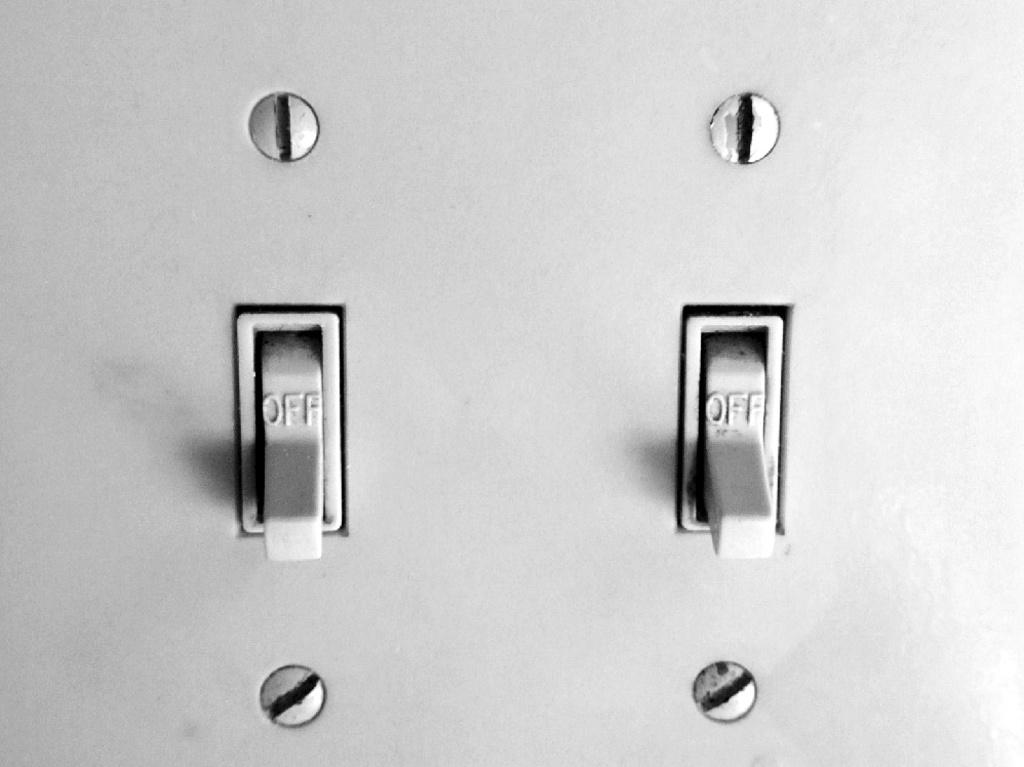<image>
Present a compact description of the photo's key features. Two light switches are currently in the off position. 